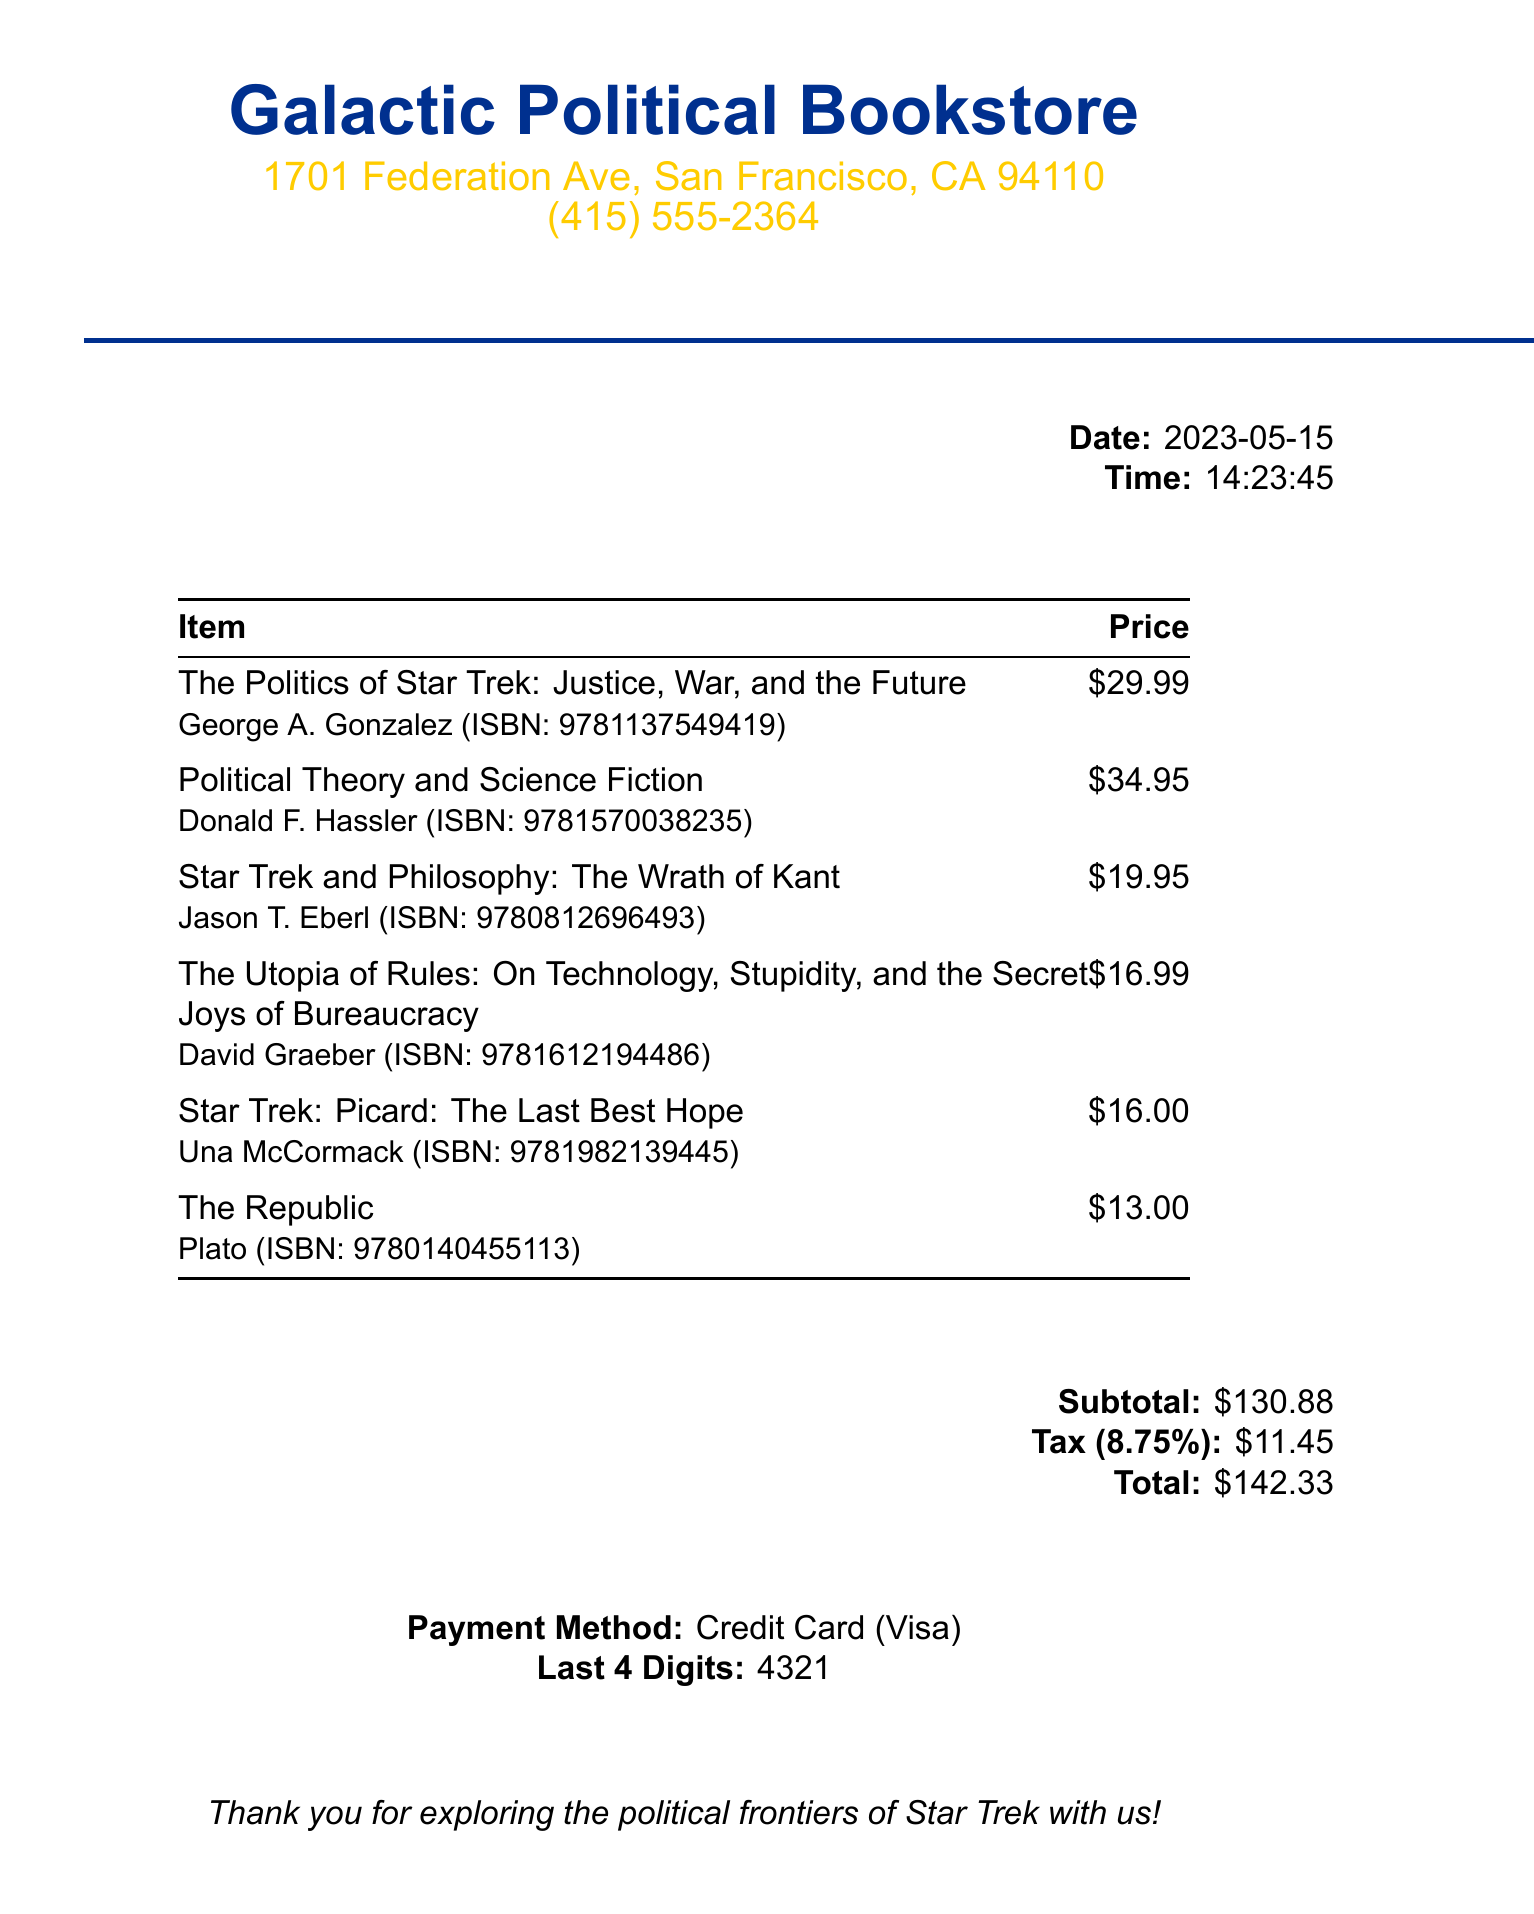What is the name of the bookstore? The name of the bookstore is prominently displayed at the top of the document.
Answer: Galactic Political Bookstore What is the total amount spent? The total amount is clearly stated at the end of the receipt under the total section.
Answer: $142.33 Who is the author of "The Republic"? The author of "The Republic" is listed right below the title on the receipt.
Answer: Plato What is the ISBN of "Star Trek: Picard: The Last Best Hope"? The ISBN for "Star Trek: Picard: The Last Best Hope" is included in smaller text below the title.
Answer: 9781982139445 What is the date of the purchase? The date of the purchase is provided in the flush right section towards the top of the receipt.
Answer: 2023-05-15 How much was the subtotal before tax? The subtotal is specified before the tax calculation in a clear area of the receipt.
Answer: $130.88 Which payment method was used? The payment method is detailed at the bottom of the receipt.
Answer: Credit Card What is the tax rate applied to the purchase? The tax rate is mentioned in the tax section under the subtotal.
Answer: 8.75% What is the price of "The Politics of Star Trek: Justice, War, and the Future"? The price is listed next to the title of the book in the itemized list.
Answer: $29.99 